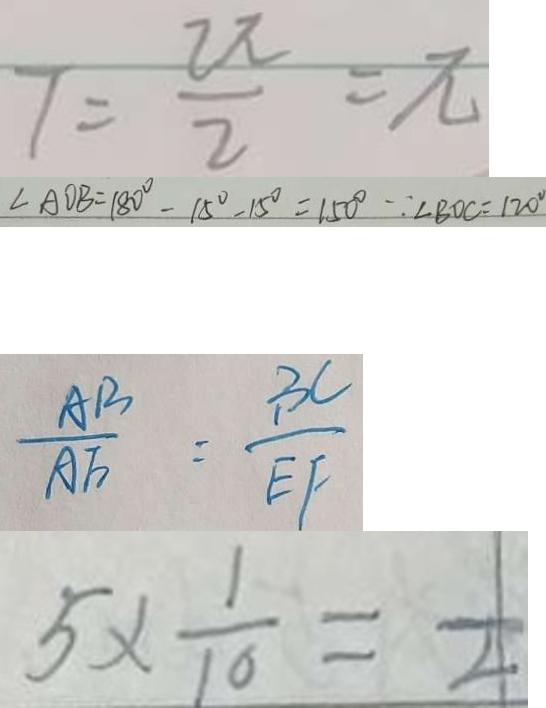Convert formula to latex. <formula><loc_0><loc_0><loc_500><loc_500>7 = \frac { 2 \pi } { 2 } = \pi 
 \angle A O B = 1 8 0 ^ { \circ } - 1 5 ^ { \circ } - 1 5 ^ { \circ } = 1 5 0 ^ { \circ } \because \angle B O C = 1 2 0 ^ { \circ } 
 \frac { A B } { A F } = \frac { B C } { E F } 
 5 \times \frac { 1 } { 1 0 } = \frac { 1 } { 4 }</formula> 